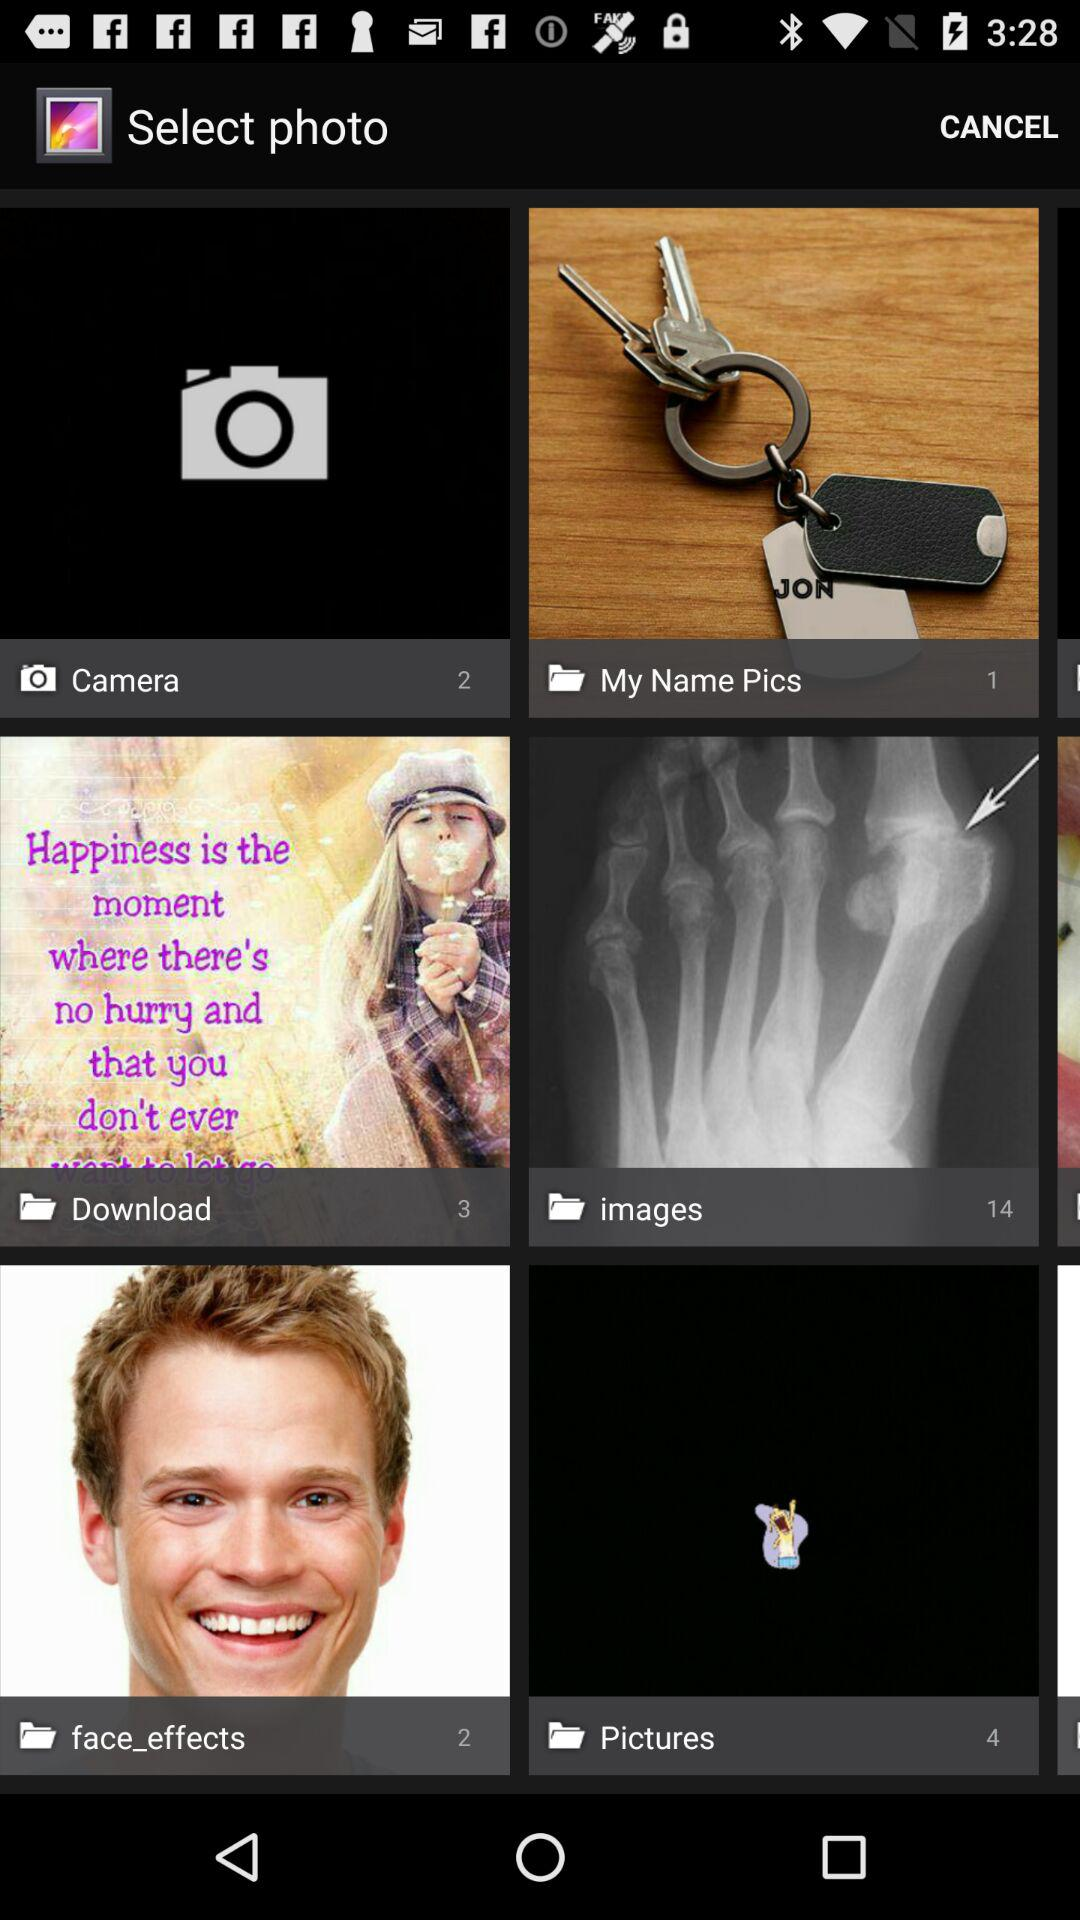What is the count of pictures in the "images" folder? There are 14 pictures in the "images" folder. 